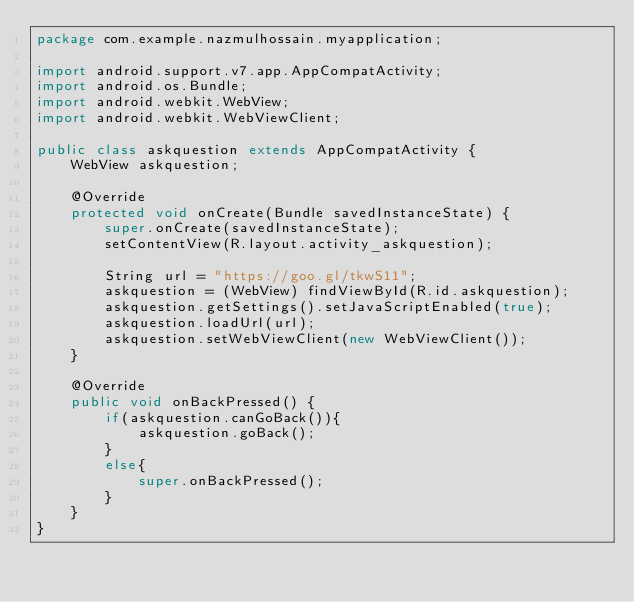<code> <loc_0><loc_0><loc_500><loc_500><_Java_>package com.example.nazmulhossain.myapplication;

import android.support.v7.app.AppCompatActivity;
import android.os.Bundle;
import android.webkit.WebView;
import android.webkit.WebViewClient;

public class askquestion extends AppCompatActivity {
    WebView askquestion;

    @Override
    protected void onCreate(Bundle savedInstanceState) {
        super.onCreate(savedInstanceState);
        setContentView(R.layout.activity_askquestion);

        String url = "https://goo.gl/tkwS11";
        askquestion = (WebView) findViewById(R.id.askquestion);
        askquestion.getSettings().setJavaScriptEnabled(true);
        askquestion.loadUrl(url);
        askquestion.setWebViewClient(new WebViewClient());
    }

    @Override
    public void onBackPressed() {
        if(askquestion.canGoBack()){
            askquestion.goBack();
        }
        else{
            super.onBackPressed();
        }
    }
}
</code> 